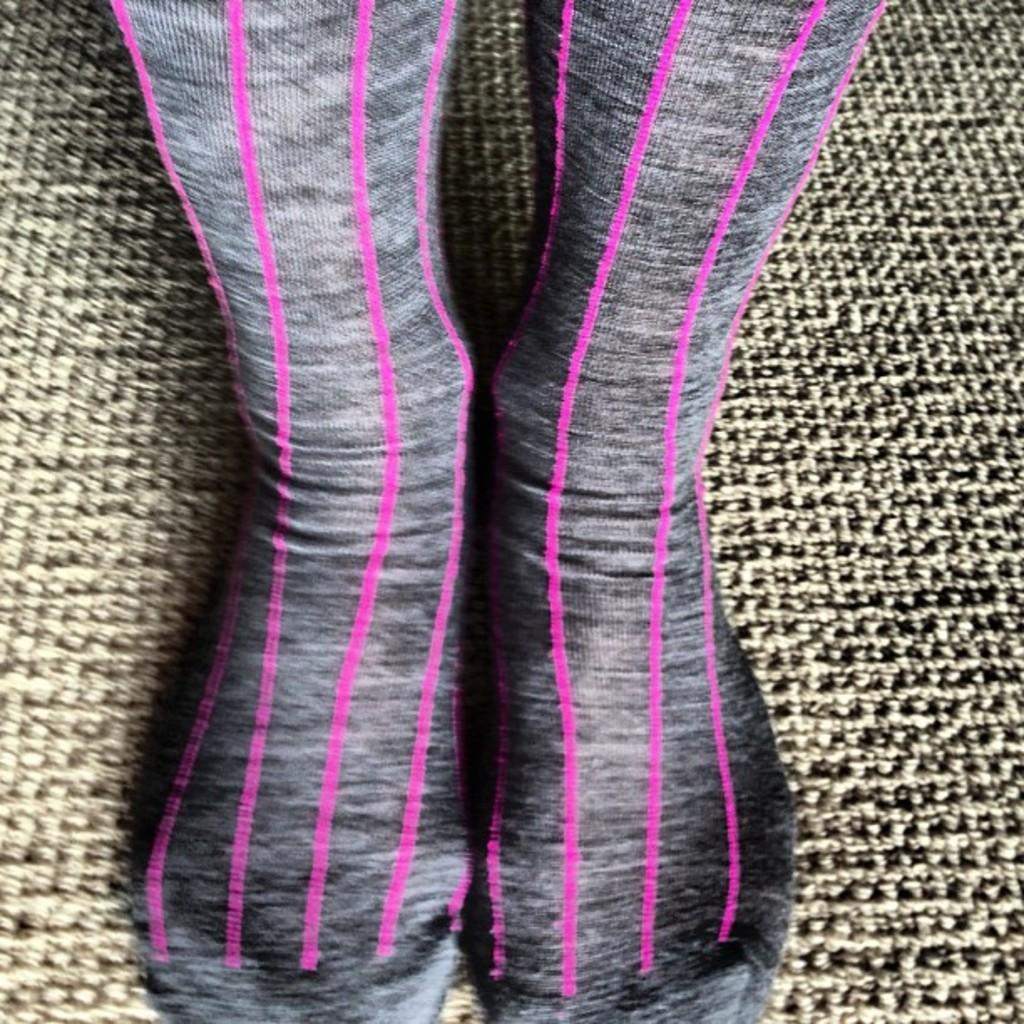What body part of a person is visible in the image? There are a person's legs in the image. What type of socks is the person wearing? The person is wearing black socks with pink stripes. What type of texture can be seen on the squirrel's fur in the image? There is no squirrel present in the image, so it is not possible to determine the texture of its fur. 